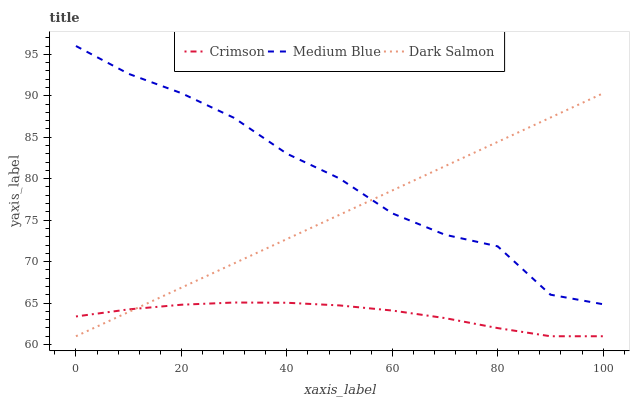Does Dark Salmon have the minimum area under the curve?
Answer yes or no. No. Does Dark Salmon have the maximum area under the curve?
Answer yes or no. No. Is Medium Blue the smoothest?
Answer yes or no. No. Is Dark Salmon the roughest?
Answer yes or no. No. Does Medium Blue have the lowest value?
Answer yes or no. No. Does Dark Salmon have the highest value?
Answer yes or no. No. Is Crimson less than Medium Blue?
Answer yes or no. Yes. Is Medium Blue greater than Crimson?
Answer yes or no. Yes. Does Crimson intersect Medium Blue?
Answer yes or no. No. 